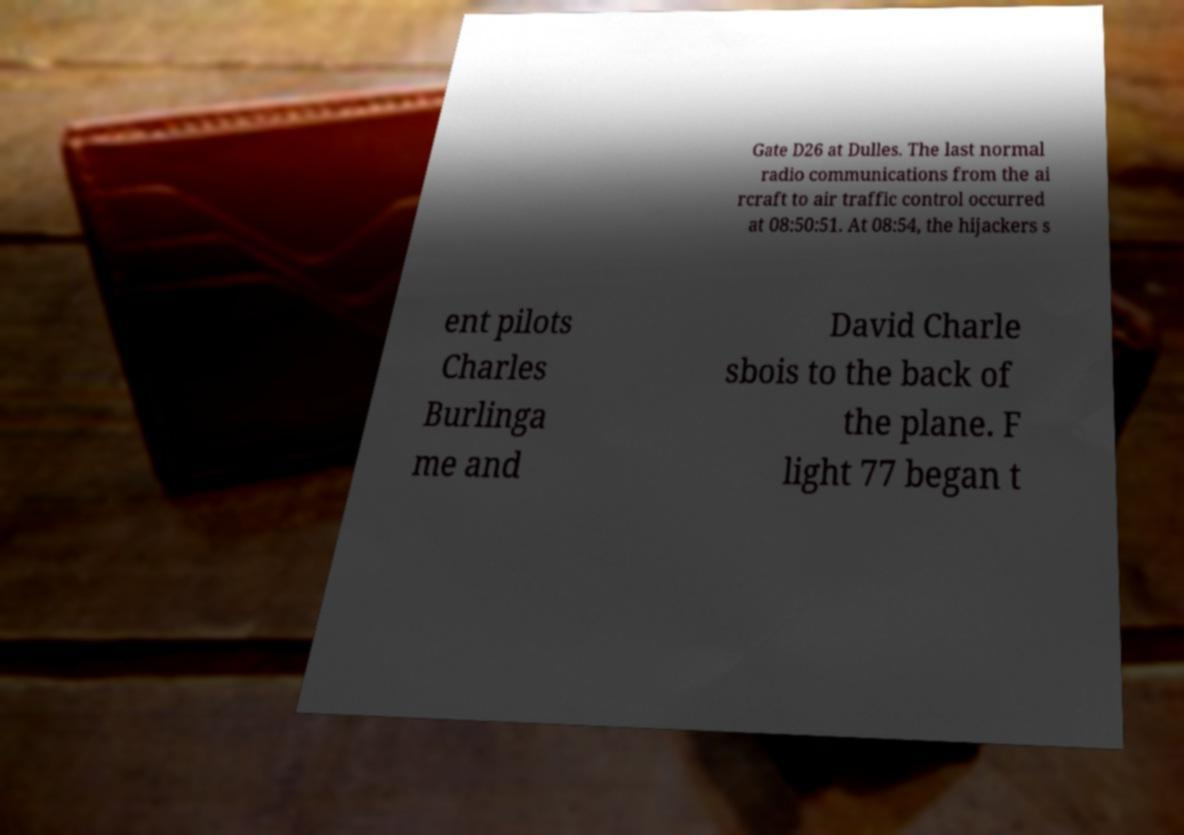Can you accurately transcribe the text from the provided image for me? Gate D26 at Dulles. The last normal radio communications from the ai rcraft to air traffic control occurred at 08:50:51. At 08:54, the hijackers s ent pilots Charles Burlinga me and David Charle sbois to the back of the plane. F light 77 began t 